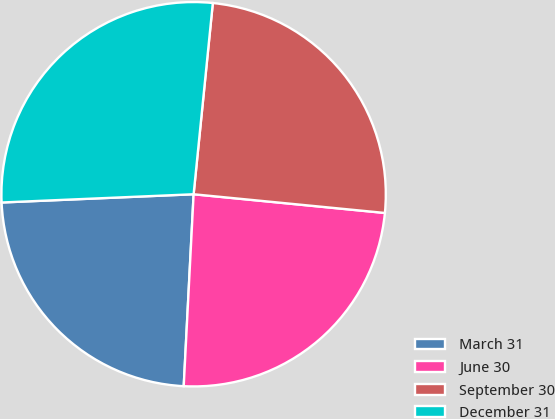Convert chart. <chart><loc_0><loc_0><loc_500><loc_500><pie_chart><fcel>March 31<fcel>June 30<fcel>September 30<fcel>December 31<nl><fcel>23.5%<fcel>24.27%<fcel>24.96%<fcel>27.28%<nl></chart> 